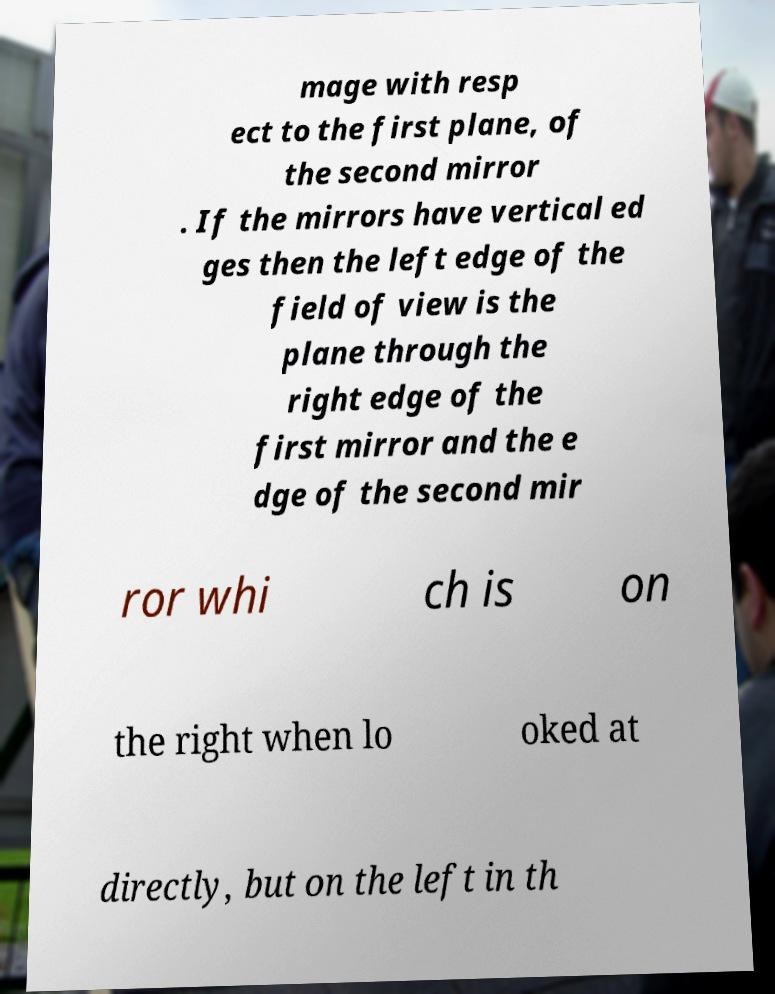Could you assist in decoding the text presented in this image and type it out clearly? mage with resp ect to the first plane, of the second mirror . If the mirrors have vertical ed ges then the left edge of the field of view is the plane through the right edge of the first mirror and the e dge of the second mir ror whi ch is on the right when lo oked at directly, but on the left in th 